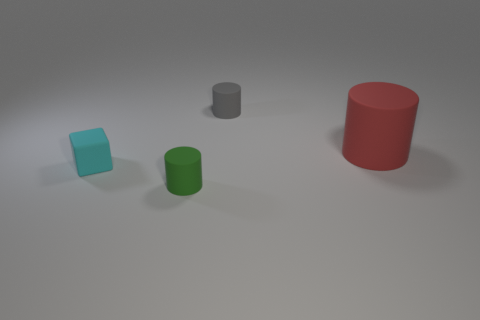Subtract all red cylinders. How many cylinders are left? 2 Add 3 big green blocks. How many objects exist? 7 Subtract all cubes. How many objects are left? 3 Subtract 2 cylinders. How many cylinders are left? 1 Subtract all gray blocks. How many red cylinders are left? 1 Subtract all red cylinders. Subtract all small blocks. How many objects are left? 2 Add 4 gray rubber objects. How many gray rubber objects are left? 5 Add 1 tiny things. How many tiny things exist? 4 Subtract 1 gray cylinders. How many objects are left? 3 Subtract all gray cylinders. Subtract all green spheres. How many cylinders are left? 2 